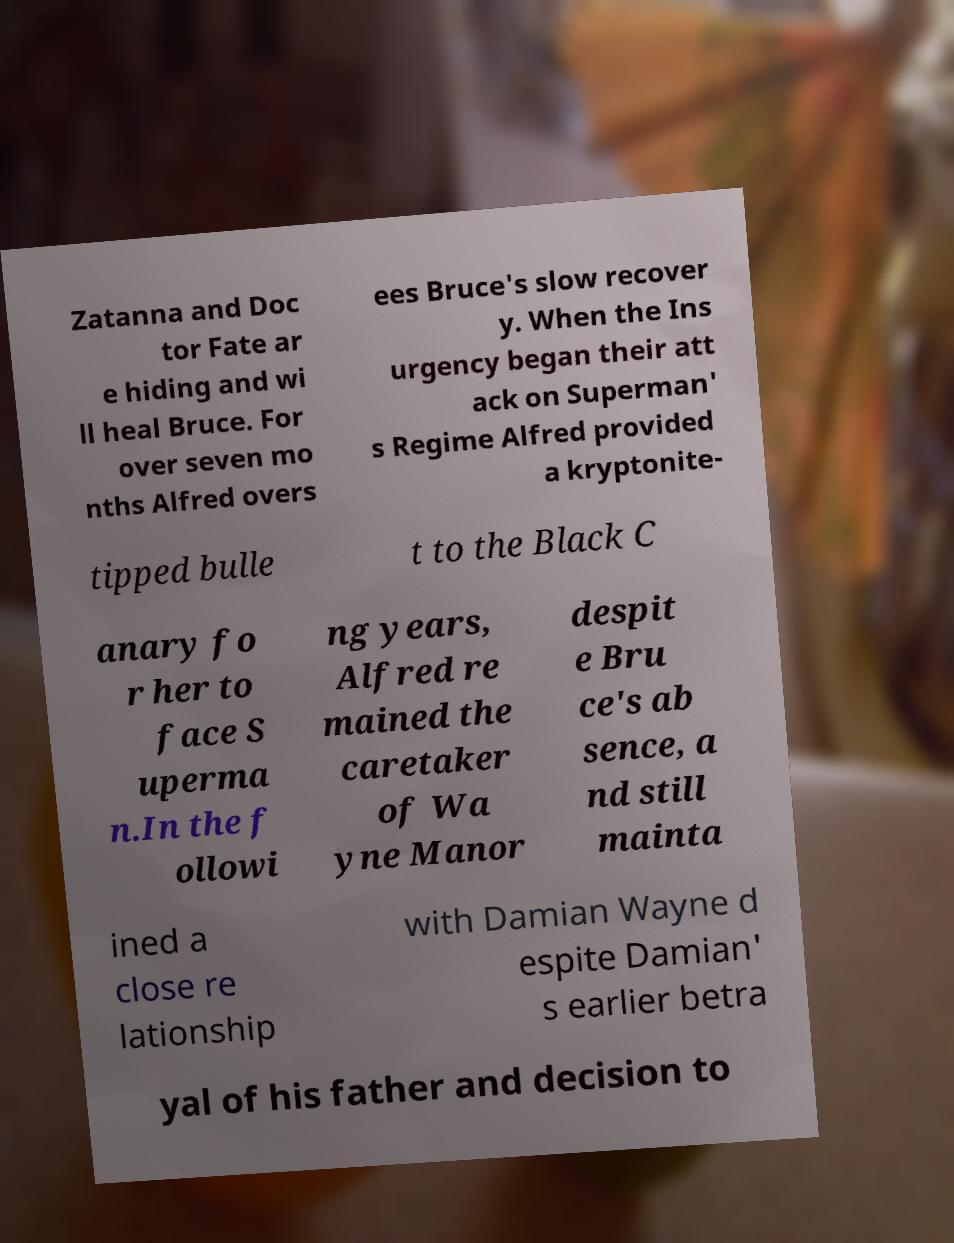Please read and relay the text visible in this image. What does it say? Zatanna and Doc tor Fate ar e hiding and wi ll heal Bruce. For over seven mo nths Alfred overs ees Bruce's slow recover y. When the Ins urgency began their att ack on Superman' s Regime Alfred provided a kryptonite- tipped bulle t to the Black C anary fo r her to face S uperma n.In the f ollowi ng years, Alfred re mained the caretaker of Wa yne Manor despit e Bru ce's ab sence, a nd still mainta ined a close re lationship with Damian Wayne d espite Damian' s earlier betra yal of his father and decision to 